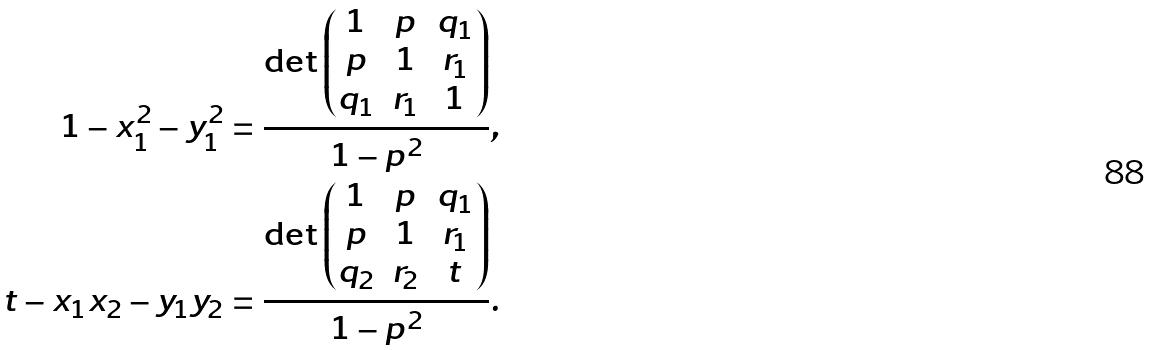Convert formula to latex. <formula><loc_0><loc_0><loc_500><loc_500>1 - x _ { 1 } ^ { 2 } - y _ { 1 } ^ { 2 } = \frac { \det \begin{pmatrix} 1 & p & q _ { 1 } \\ p & 1 & r _ { 1 } \\ q _ { 1 } & r _ { 1 } & 1 \end{pmatrix} } { 1 - p ^ { 2 } } , \\ t - x _ { 1 } x _ { 2 } - y _ { 1 } y _ { 2 } = \frac { \det \begin{pmatrix} 1 & p & q _ { 1 } \\ p & 1 & r _ { 1 } \\ q _ { 2 } & r _ { 2 } & t \end{pmatrix} } { 1 - p ^ { 2 } } .</formula> 